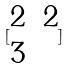Convert formula to latex. <formula><loc_0><loc_0><loc_500><loc_500>[ \begin{matrix} 2 & 2 \\ 3 \end{matrix} ]</formula> 